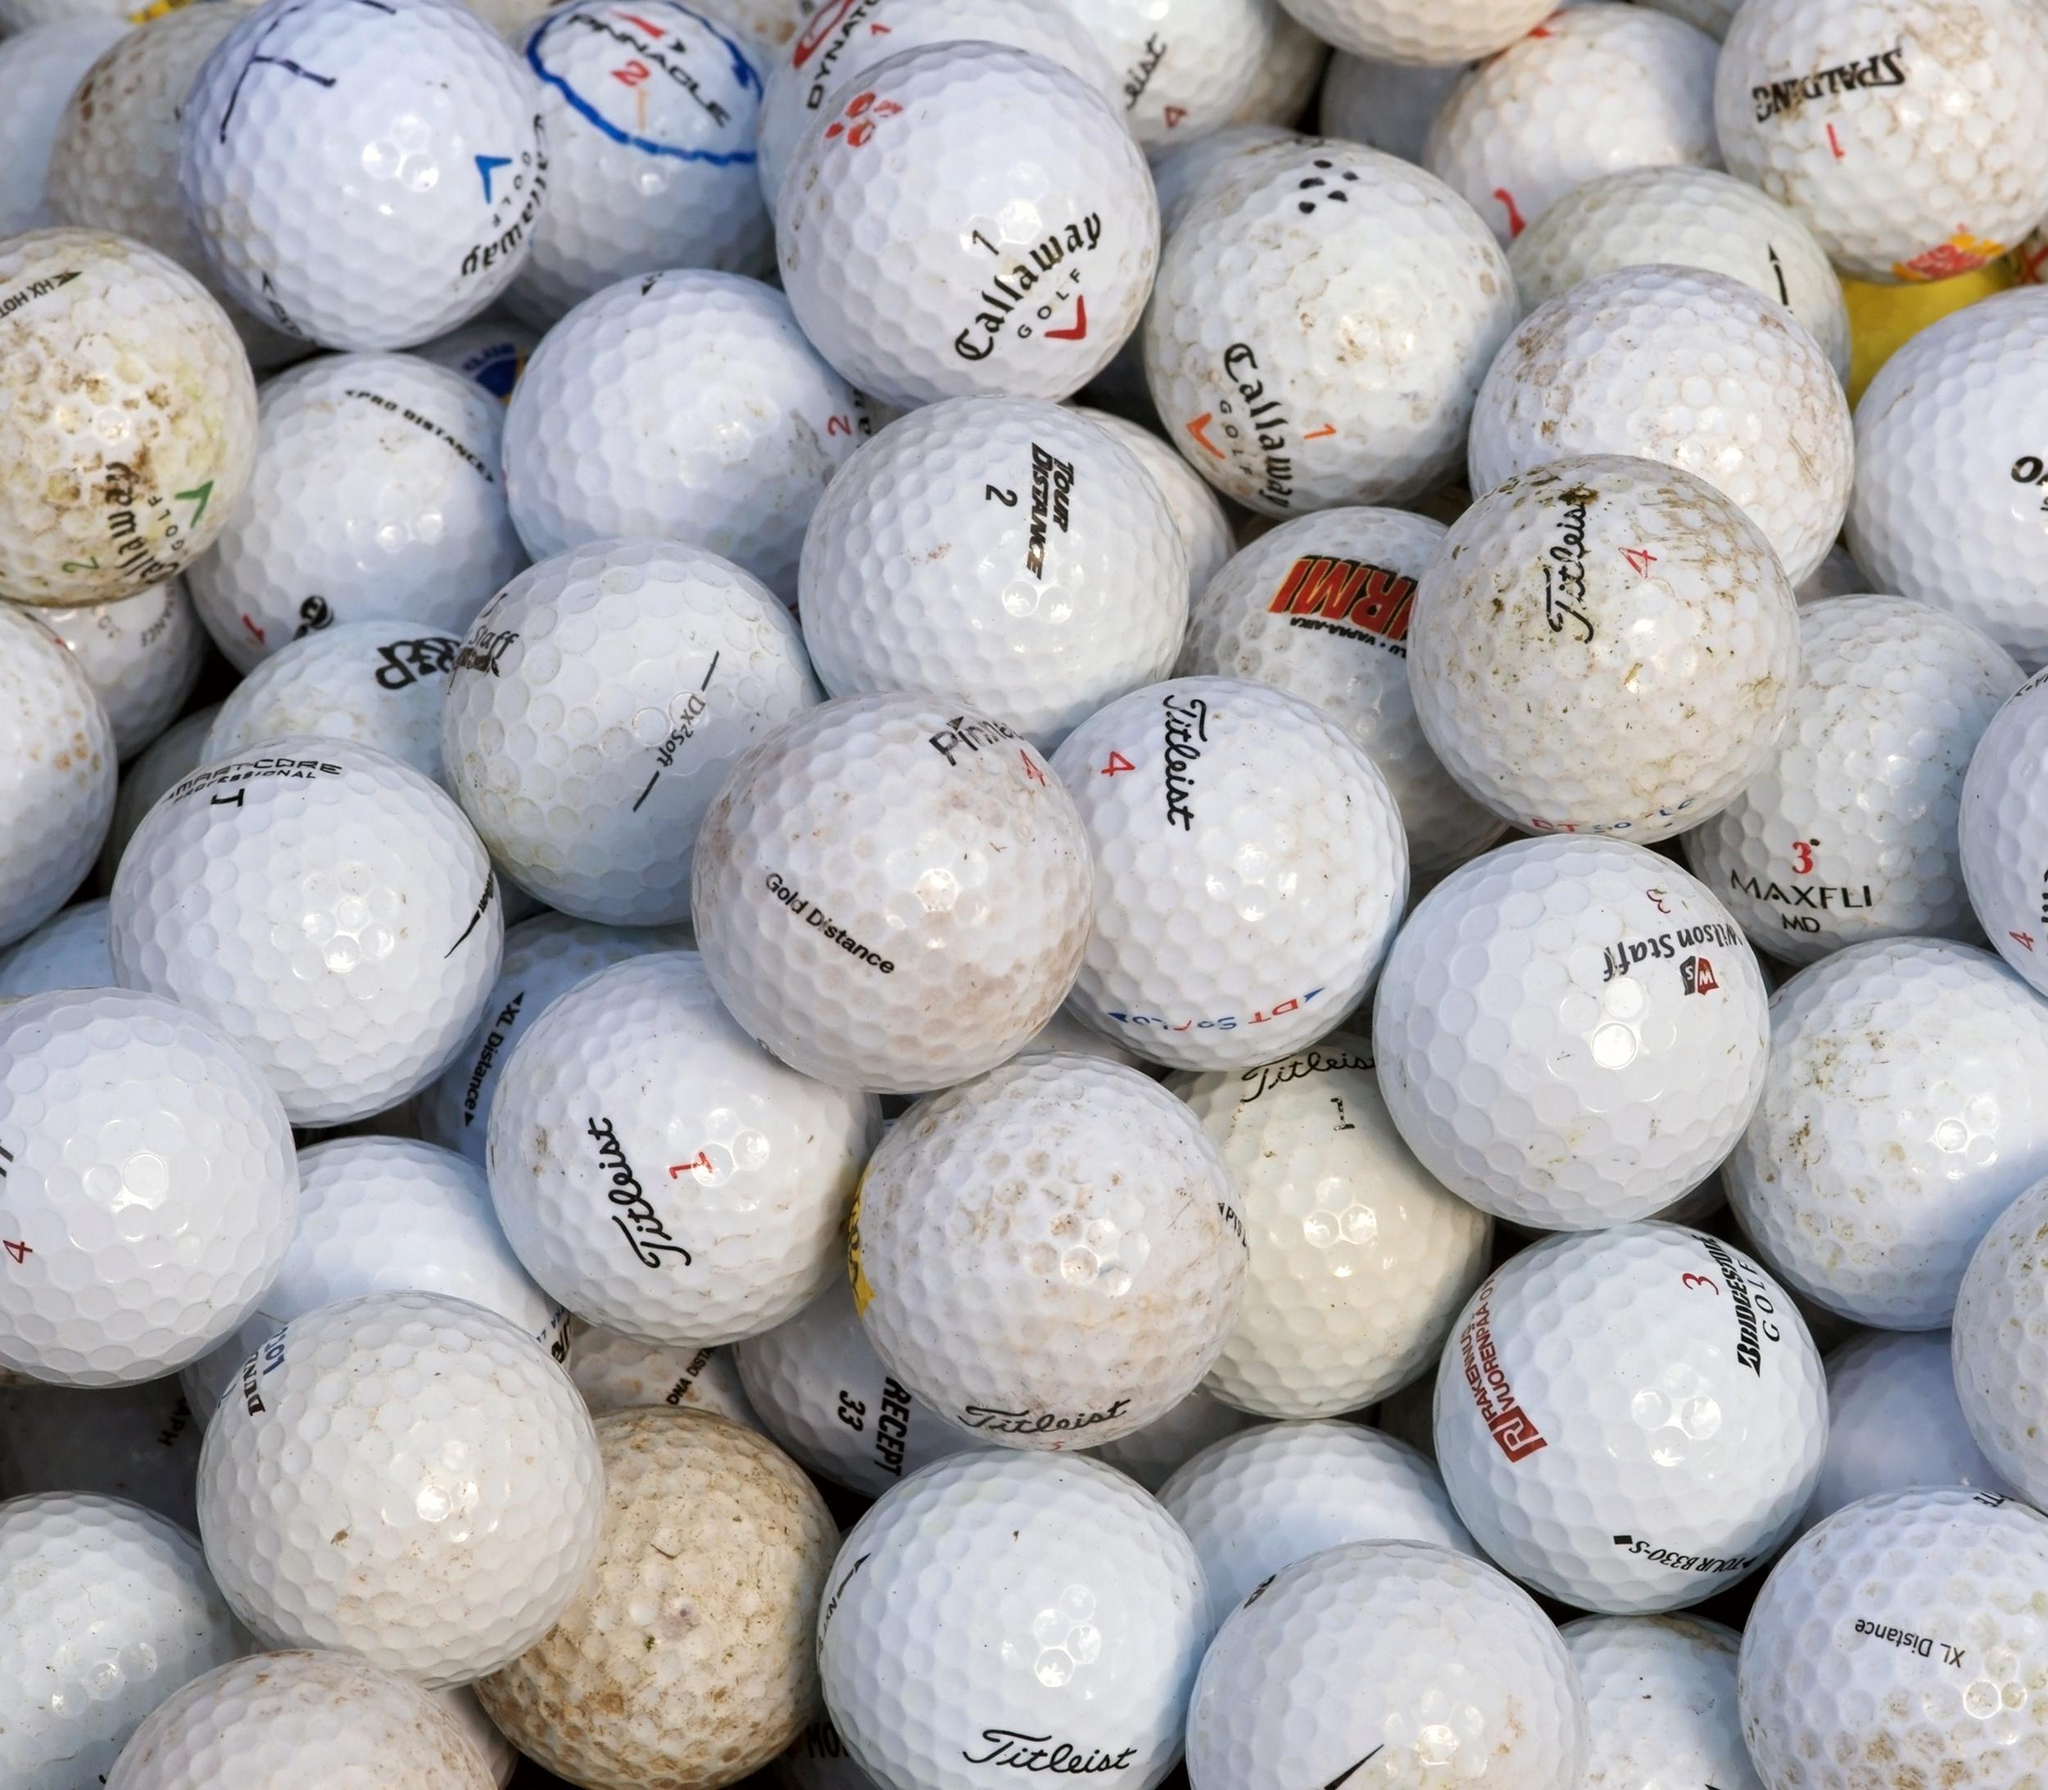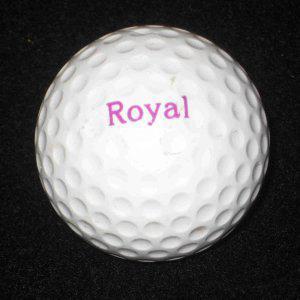The first image is the image on the left, the second image is the image on the right. Assess this claim about the two images: "The left and right image contains a total of two golf balls.". Correct or not? Answer yes or no. No. 